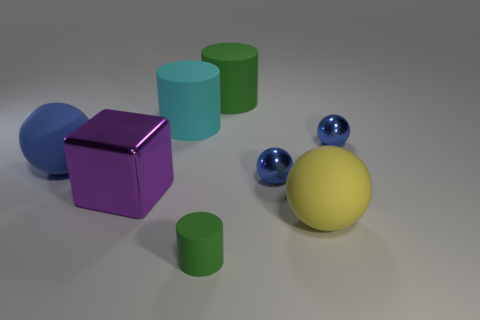Does the ball that is to the left of the big cyan cylinder have the same material as the large purple cube?
Give a very brief answer. No. Is there a green metallic cylinder that has the same size as the cyan thing?
Offer a very short reply. No. Is the shape of the small rubber thing the same as the green thing behind the large shiny cube?
Make the answer very short. Yes. There is a matte thing that is in front of the rubber ball in front of the purple cube; are there any big metallic cubes on the right side of it?
Your answer should be compact. No. The cyan cylinder has what size?
Provide a short and direct response. Large. How many other things are the same color as the metallic block?
Make the answer very short. 0. There is a blue thing left of the big purple shiny block; is its shape the same as the yellow thing?
Offer a terse response. Yes. There is another big thing that is the same shape as the big green matte object; what is its color?
Your response must be concise. Cyan. What size is the blue rubber object that is the same shape as the yellow thing?
Keep it short and to the point. Large. There is a object that is both behind the small matte object and in front of the metal block; what material is it made of?
Ensure brevity in your answer.  Rubber. 